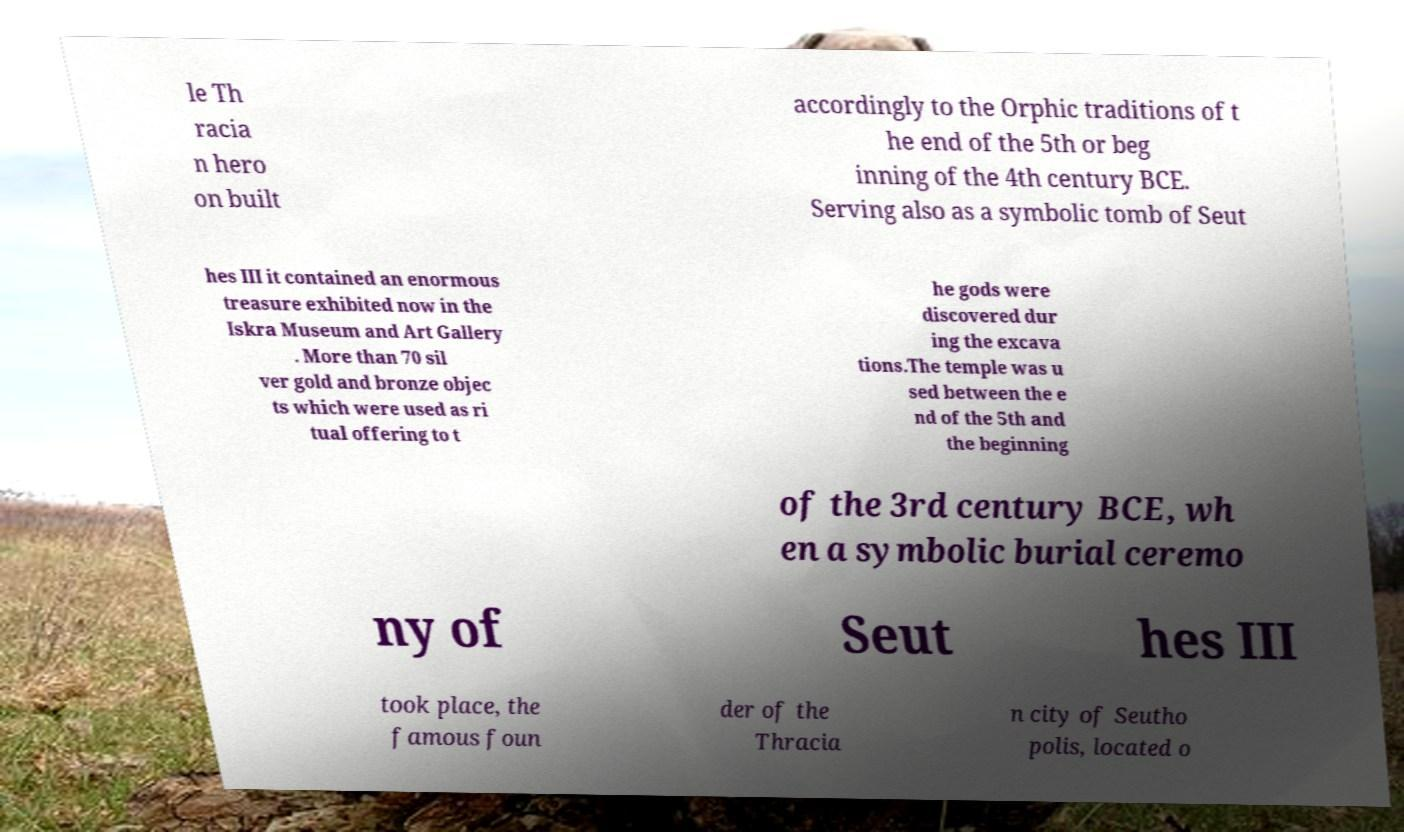Can you accurately transcribe the text from the provided image for me? le Th racia n hero on built accordingly to the Orphic traditions of t he end of the 5th or beg inning of the 4th century BCE. Serving also as a symbolic tomb of Seut hes III it contained an enormous treasure exhibited now in the Iskra Museum and Art Gallery . More than 70 sil ver gold and bronze objec ts which were used as ri tual offering to t he gods were discovered dur ing the excava tions.The temple was u sed between the e nd of the 5th and the beginning of the 3rd century BCE, wh en a symbolic burial ceremo ny of Seut hes III took place, the famous foun der of the Thracia n city of Seutho polis, located o 